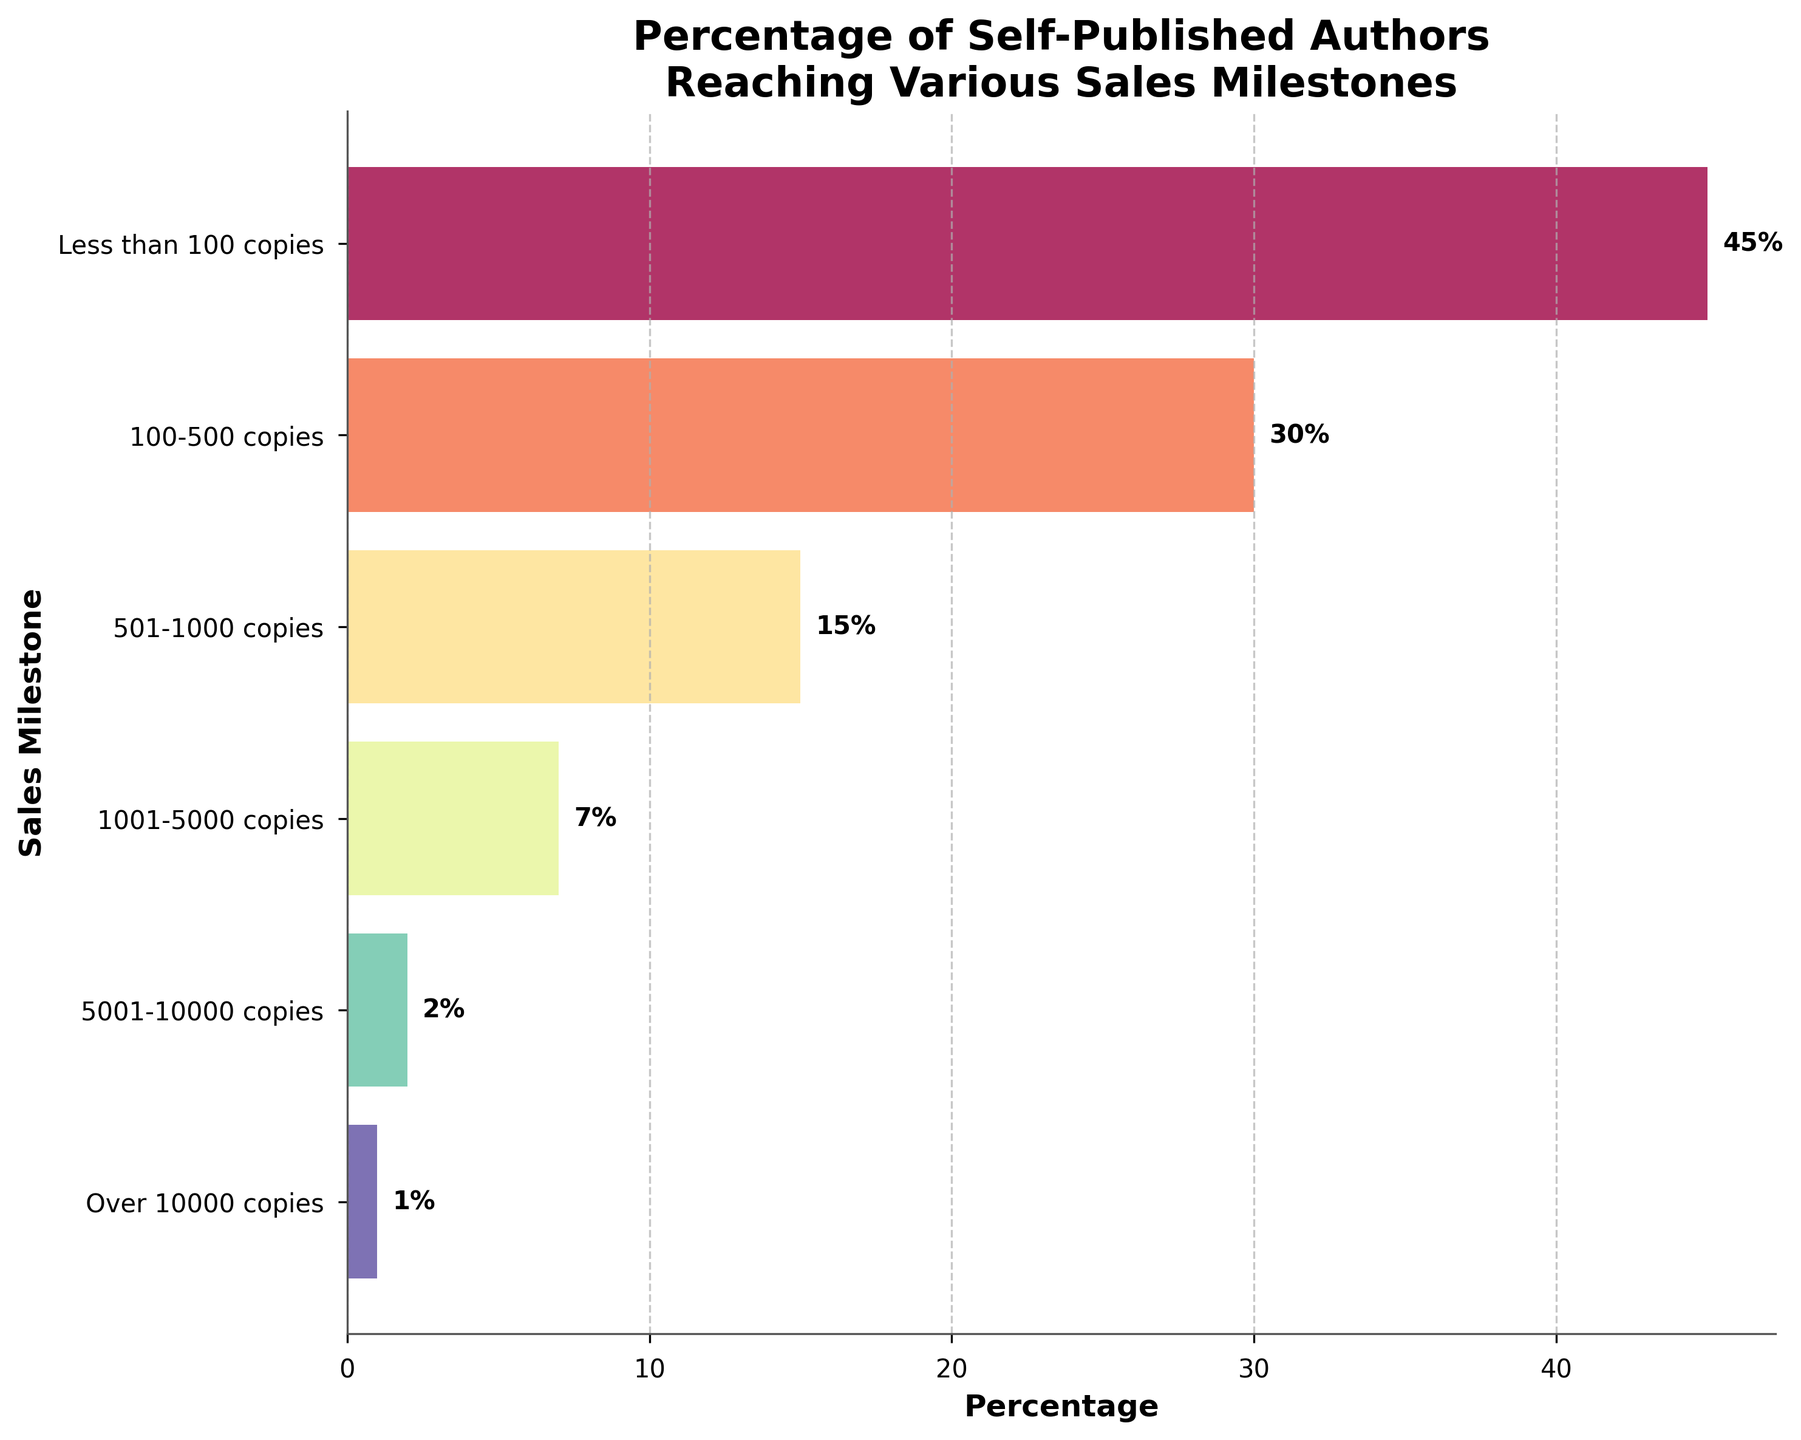what is the title of the plot? The title of the plot is located at the top center and reads 'Percentage of Self-Published Authors Reaching Various Sales Milestones'.
Answer: Percentage of Self-Published Authors Reaching Various Sales Milestones Which sales milestone has the highest percentage of self-published authors? By looking at the bars, the sales milestone with the longest bar represents the highest percentage. This is 'Less than 100 copies' with a percentage of 45%.
Answer: Less than 100 copies How many sales milestones are shown in the chart? Count the number of bars or unique labels on the y-axis. There are six sales milestones shown.
Answer: Six What is the percentage of self-published authors that sold between 501-1000 copies? Look for the bar labeled '501-1000 copies' and read the corresponding percentage, which is 15%.
Answer: 15% Which sales milestone has the lowest percentage of self-published authors? Identify the bar with the smallest length, which is 'Over 10000 copies' with a 1% percentage.
Answer: Over 10000 copies How much higher is the percentage of authors selling less than 100 copies compared to those selling between 100-500 copies? Subtract the percentage of '100-500 copies' from 'Less than 100 copies': 45% - 30% = 15%.
Answer: 15% What is the combined percentage of self-published authors that sold more than 5000 copies? Add the percentages of '5001-10000 copies' (2%) and 'Over 10000 copies' (1%): 2% + 1% = 3%.
Answer: 3% Which sales milestones have a lower percentage than those selling 1001-5000 copies? Compare '1001-5000 copies' (7%) with all milestones. Those lower are '5001-10000 copies' (2%) and 'Over 10000 copies' (1%).
Answer: 5001-10000 copies, Over 10000 copies What percentage of authors sold between 1001-5000 copies and 5001-10000 copies combined? Add the percentages of the two ranges: 7% (1001-5000 copies) + 2% (5001-10000 copies) = 9%.
Answer: 9% What is the difference in percentage between the highest and lowest sales milestone categories? Subtract the lowest percentage (1% from 'Over 10000 copies') from the highest percentage (45% from 'Less than 100 copies'): 45% - 1% = 44%.
Answer: 44% 